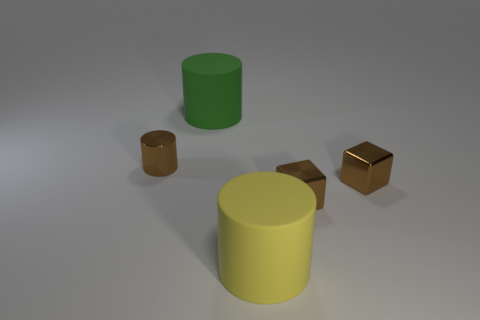Add 1 tiny objects. How many objects exist? 6 Subtract all cylinders. How many objects are left? 2 Subtract 0 green spheres. How many objects are left? 5 Subtract all green cylinders. Subtract all small brown metallic cylinders. How many objects are left? 3 Add 3 tiny brown cylinders. How many tiny brown cylinders are left? 4 Add 5 cyan shiny things. How many cyan shiny things exist? 5 